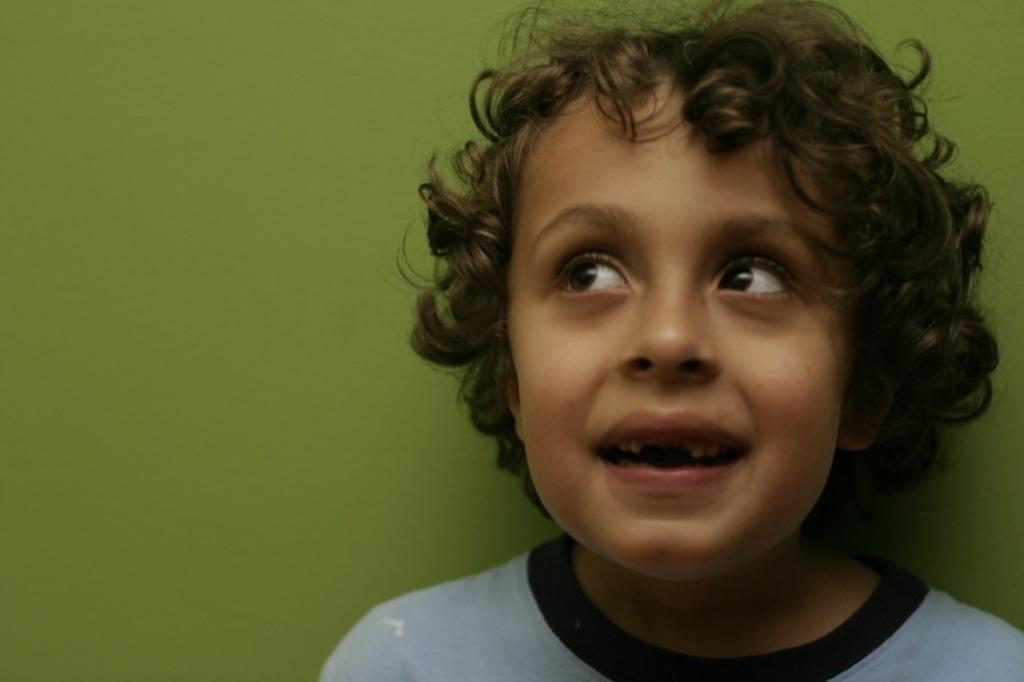What is the main subject in the foreground of the image? There is a boy in the foreground of the image. What color is predominant in the background of the image? The background of the image is green. What type of beef can be seen in the image? There is no beef present in the image. How does the boy burst into laughter in the image? The boy does not burst into laughter in the image; there is no indication of his emotional state. 